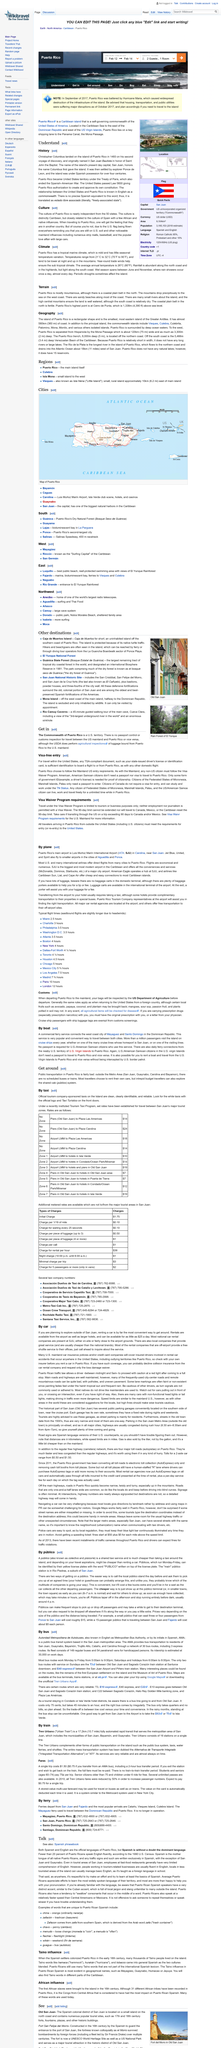Highlight a few significant elements in this photo. Forty years of Spanish rule in Puerto Rico came to an end with the signing of the Treaty of Paris. There is no precise Spanish equivalent to the English word 'commonwealth'. Christopher Columbus landed on the island of Puerto Rico in 1493. 